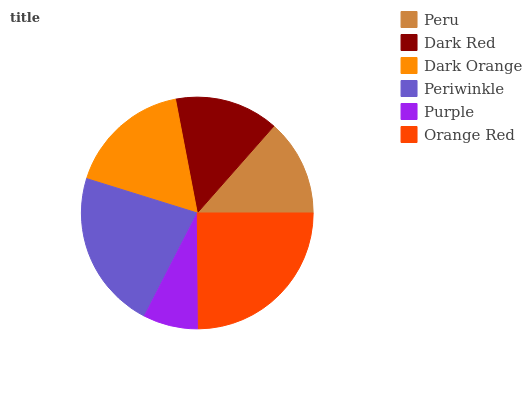Is Purple the minimum?
Answer yes or no. Yes. Is Orange Red the maximum?
Answer yes or no. Yes. Is Dark Red the minimum?
Answer yes or no. No. Is Dark Red the maximum?
Answer yes or no. No. Is Dark Red greater than Peru?
Answer yes or no. Yes. Is Peru less than Dark Red?
Answer yes or no. Yes. Is Peru greater than Dark Red?
Answer yes or no. No. Is Dark Red less than Peru?
Answer yes or no. No. Is Dark Orange the high median?
Answer yes or no. Yes. Is Dark Red the low median?
Answer yes or no. Yes. Is Peru the high median?
Answer yes or no. No. Is Dark Orange the low median?
Answer yes or no. No. 